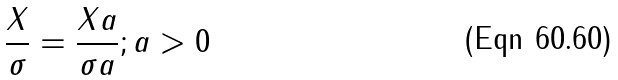<formula> <loc_0><loc_0><loc_500><loc_500>\frac { X } { \sigma } = \frac { X a } { \sigma a } ; a > 0</formula> 